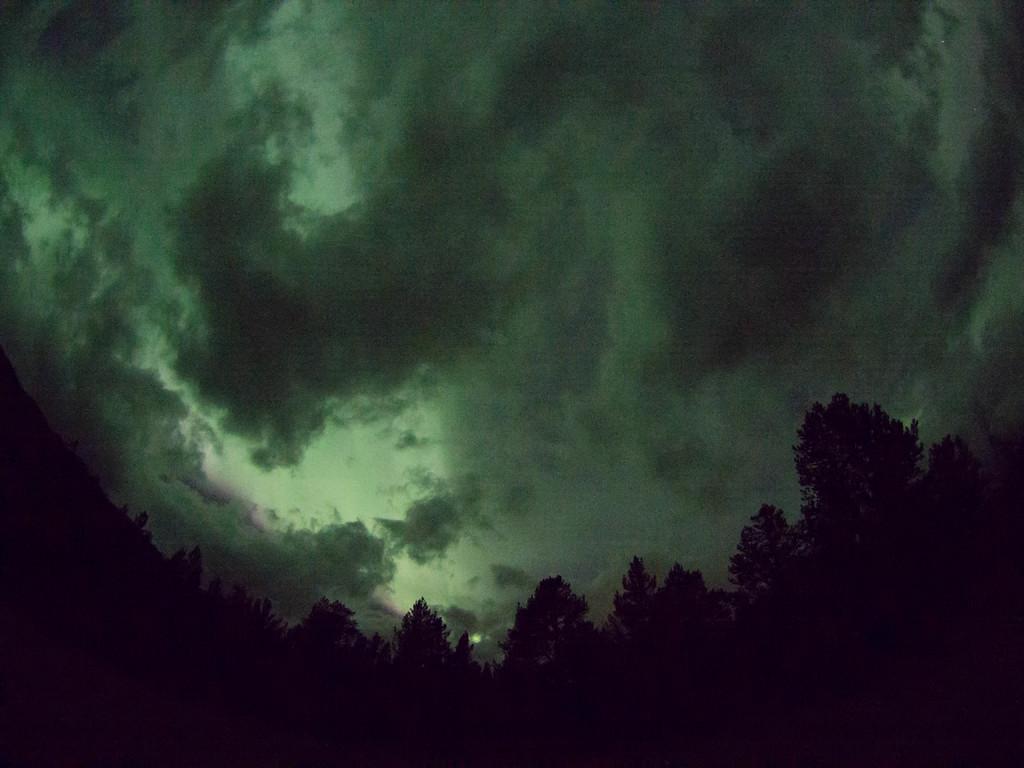Can you describe this image briefly? Here in this picture we can see trees present all over there and we can see the sky is fully covered with clouds over there. 